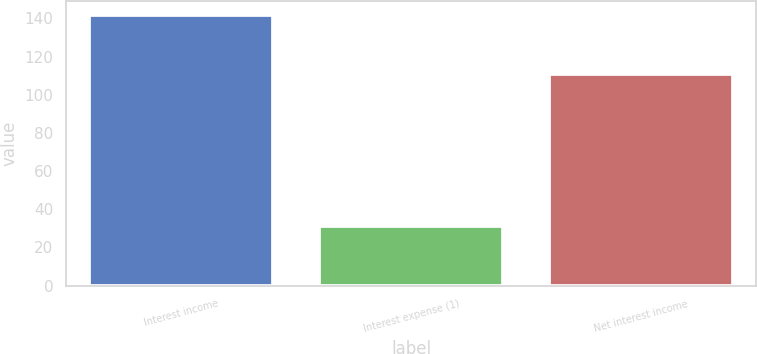<chart> <loc_0><loc_0><loc_500><loc_500><bar_chart><fcel>Interest income<fcel>Interest expense (1)<fcel>Net interest income<nl><fcel>142<fcel>31<fcel>111<nl></chart> 